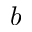Convert formula to latex. <formula><loc_0><loc_0><loc_500><loc_500>b</formula> 